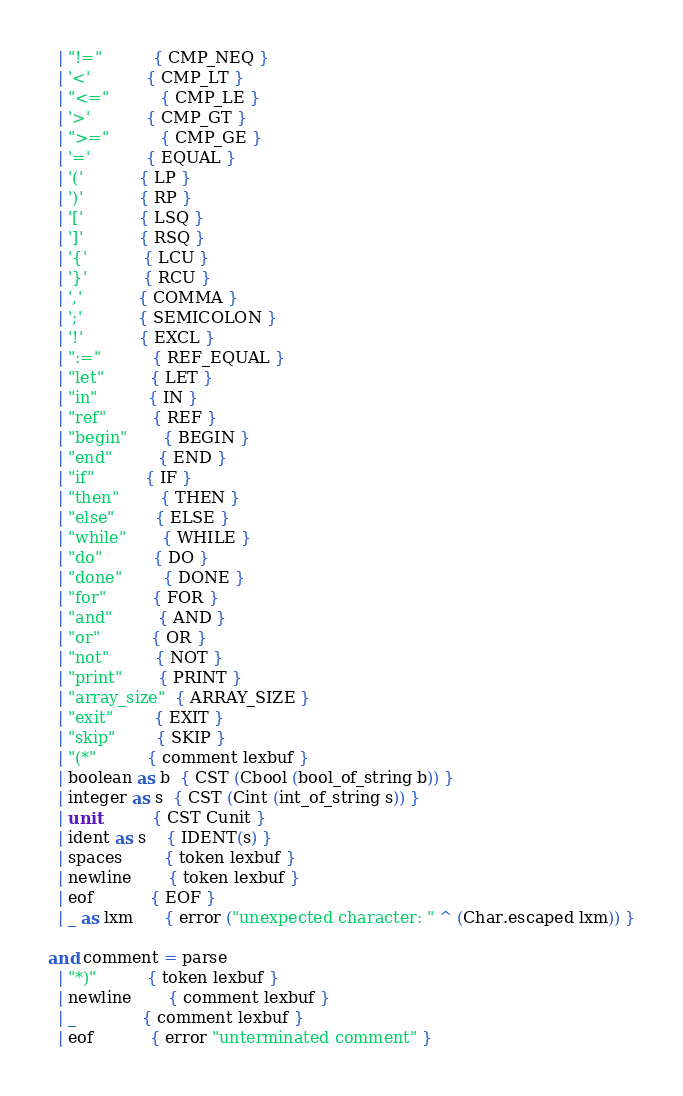<code> <loc_0><loc_0><loc_500><loc_500><_OCaml_>  | "!="          { CMP_NEQ }
  | '<'           { CMP_LT }
  | "<="          { CMP_LE }
  | '>'           { CMP_GT }
  | ">="          { CMP_GE }
  | '='           { EQUAL }
  | '('           { LP }
  | ')'           { RP }
  | '['           { LSQ }
  | ']'           { RSQ }
  | '{'           { LCU }
  | '}'           { RCU }
  | ','           { COMMA }
  | ';'           { SEMICOLON }
  | '!'           { EXCL }
  | ":="          { REF_EQUAL }
  | "let"         { LET }
  | "in"          { IN }
  | "ref"         { REF }
  | "begin"       { BEGIN }
  | "end"         { END }
  | "if"          { IF }
  | "then"        { THEN }
  | "else"        { ELSE }
  | "while"       { WHILE }
  | "do"          { DO }
  | "done"        { DONE }
  | "for"         { FOR }
  | "and"         { AND }
  | "or"          { OR }
  | "not"         { NOT }
  | "print"       { PRINT }
  | "array_size"  { ARRAY_SIZE }
  | "exit"        { EXIT }
  | "skip"        { SKIP }
  | "(*"          { comment lexbuf }
  | boolean as b  { CST (Cbool (bool_of_string b)) }
  | integer as s  { CST (Cint (int_of_string s)) }
  | unit          { CST Cunit }
  | ident as s    { IDENT(s) }
  | spaces        { token lexbuf }
  | newline       { token lexbuf }
  | eof           { EOF }
  | _ as lxm      { error ("unexpected character: " ^ (Char.escaped lxm)) }

and comment = parse
  | "*)"          { token lexbuf }
  | newline       { comment lexbuf }
  | _             { comment lexbuf }
  | eof           { error "unterminated comment" }</code> 